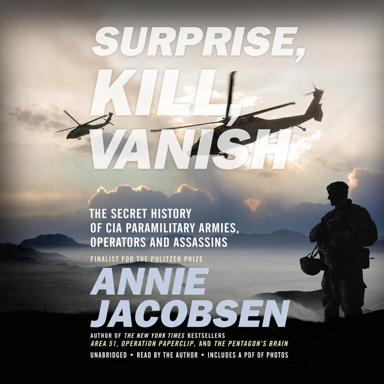What is the title of the book mentioned in the image? The book showcased in the image is titled "Surprise, Kill, Vanish: The Secret History of CIA Paramilitary Armies, Operators, and Assassins," authored by Annie Jacobsen. This book dives deep into the clandestine operations and strategies adopted by the CIA. 